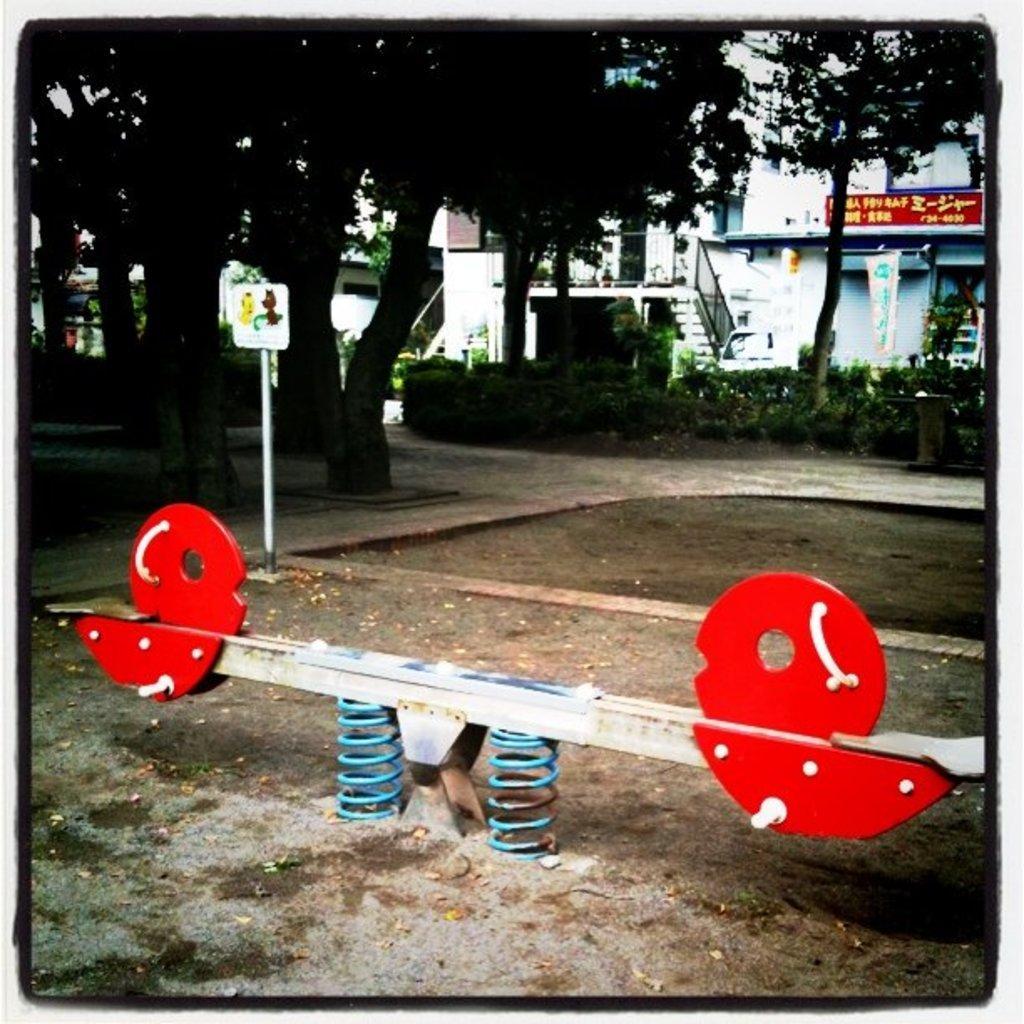Please provide a concise description of this image. In this image there is a see-saw game. There is sand. There is a road. There are trees and plants. There are buildings. There are boards. 